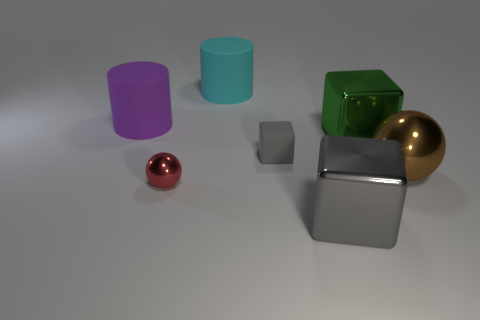Are there any other blocks of the same color as the rubber block?
Make the answer very short. Yes. How many metal things are large balls or blocks?
Offer a terse response. 3. Are there any brown objects made of the same material as the brown sphere?
Offer a very short reply. No. How many objects are behind the big gray metal block and on the right side of the red metallic object?
Provide a short and direct response. 4. Are there fewer rubber cubes in front of the purple cylinder than things that are in front of the large cyan rubber thing?
Provide a short and direct response. Yes. Does the tiny matte thing have the same shape as the gray shiny object?
Your answer should be very brief. Yes. How many other things are the same size as the red metal ball?
Provide a succinct answer. 1. What number of things are either big metal objects in front of the green shiny thing or big cylinders in front of the cyan thing?
Your response must be concise. 3. How many other large cyan things are the same shape as the big cyan matte object?
Offer a very short reply. 0. The big object that is right of the purple matte thing and left of the small matte thing is made of what material?
Offer a very short reply. Rubber. 